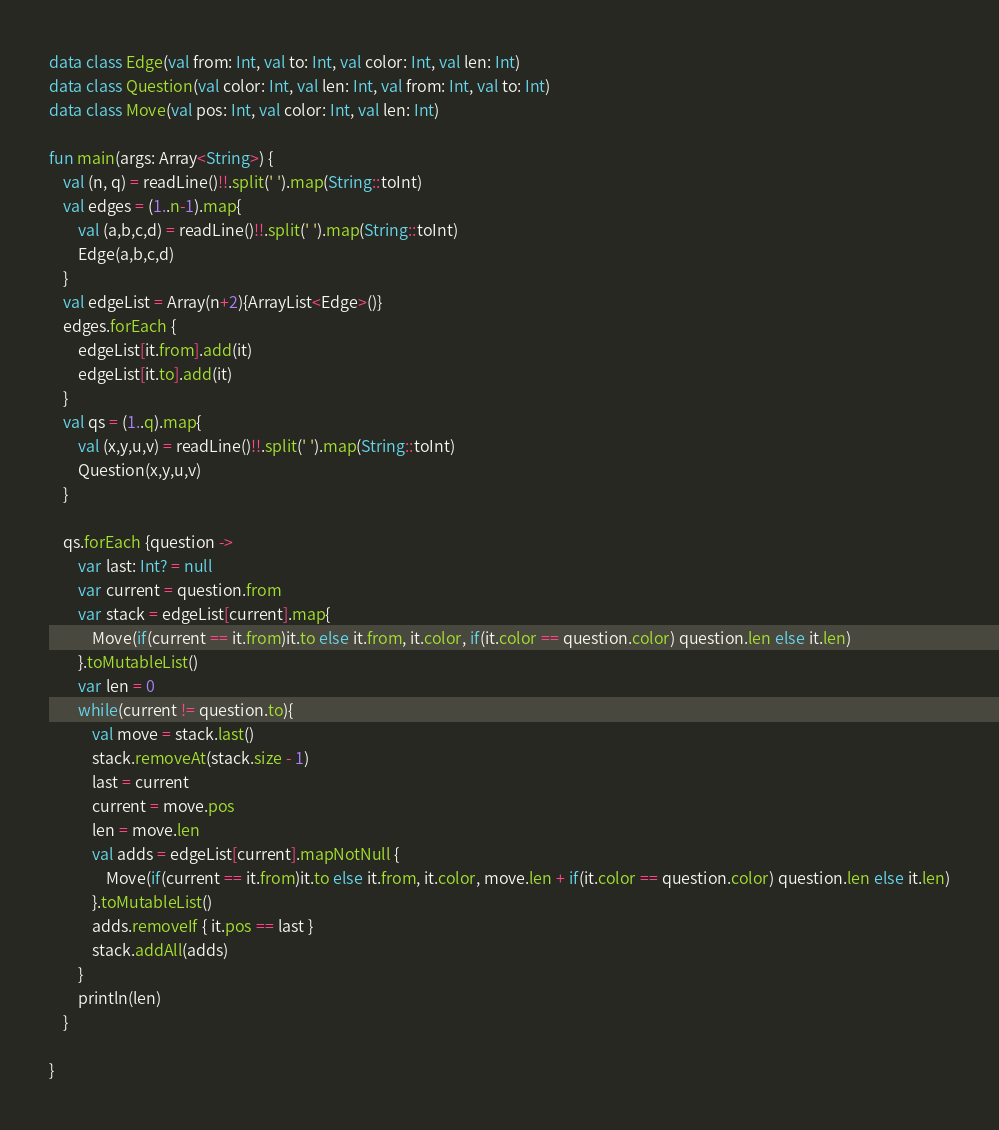Convert code to text. <code><loc_0><loc_0><loc_500><loc_500><_Kotlin_>data class Edge(val from: Int, val to: Int, val color: Int, val len: Int)
data class Question(val color: Int, val len: Int, val from: Int, val to: Int)
data class Move(val pos: Int, val color: Int, val len: Int)

fun main(args: Array<String>) {
    val (n, q) = readLine()!!.split(' ').map(String::toInt)
    val edges = (1..n-1).map{
        val (a,b,c,d) = readLine()!!.split(' ').map(String::toInt)
        Edge(a,b,c,d)
    }
    val edgeList = Array(n+2){ArrayList<Edge>()}
    edges.forEach {
        edgeList[it.from].add(it)
        edgeList[it.to].add(it)
    }
    val qs = (1..q).map{
        val (x,y,u,v) = readLine()!!.split(' ').map(String::toInt)
        Question(x,y,u,v)
    }

    qs.forEach {question ->
        var last: Int? = null
        var current = question.from
        var stack = edgeList[current].map{
            Move(if(current == it.from)it.to else it.from, it.color, if(it.color == question.color) question.len else it.len)
        }.toMutableList()
        var len = 0
        while(current != question.to){
            val move = stack.last()
            stack.removeAt(stack.size - 1)
            last = current
            current = move.pos
            len = move.len
            val adds = edgeList[current].mapNotNull {
                Move(if(current == it.from)it.to else it.from, it.color, move.len + if(it.color == question.color) question.len else it.len)
            }.toMutableList()
            adds.removeIf { it.pos == last }
            stack.addAll(adds)
        }
        println(len)
    }

}</code> 